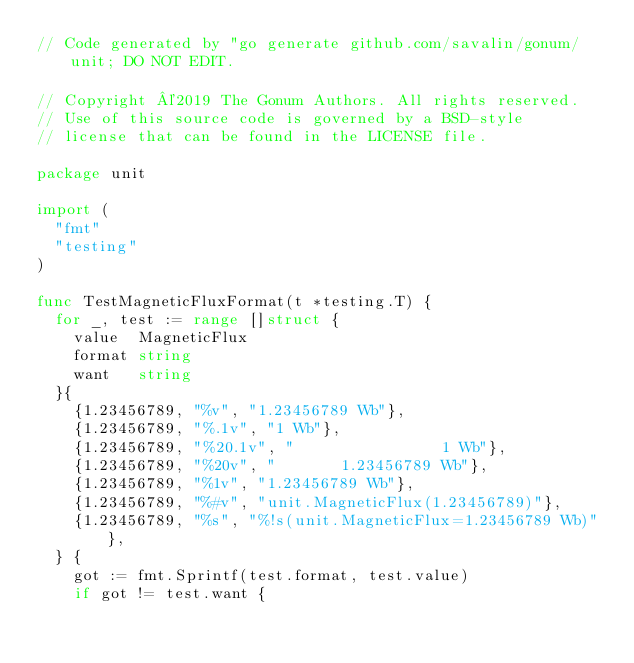<code> <loc_0><loc_0><loc_500><loc_500><_Go_>// Code generated by "go generate github.com/savalin/gonum/unit; DO NOT EDIT.

// Copyright ©2019 The Gonum Authors. All rights reserved.
// Use of this source code is governed by a BSD-style
// license that can be found in the LICENSE file.

package unit

import (
	"fmt"
	"testing"
)

func TestMagneticFluxFormat(t *testing.T) {
	for _, test := range []struct {
		value  MagneticFlux
		format string
		want   string
	}{
		{1.23456789, "%v", "1.23456789 Wb"},
		{1.23456789, "%.1v", "1 Wb"},
		{1.23456789, "%20.1v", "                1 Wb"},
		{1.23456789, "%20v", "       1.23456789 Wb"},
		{1.23456789, "%1v", "1.23456789 Wb"},
		{1.23456789, "%#v", "unit.MagneticFlux(1.23456789)"},
		{1.23456789, "%s", "%!s(unit.MagneticFlux=1.23456789 Wb)"},
	} {
		got := fmt.Sprintf(test.format, test.value)
		if got != test.want {</code> 